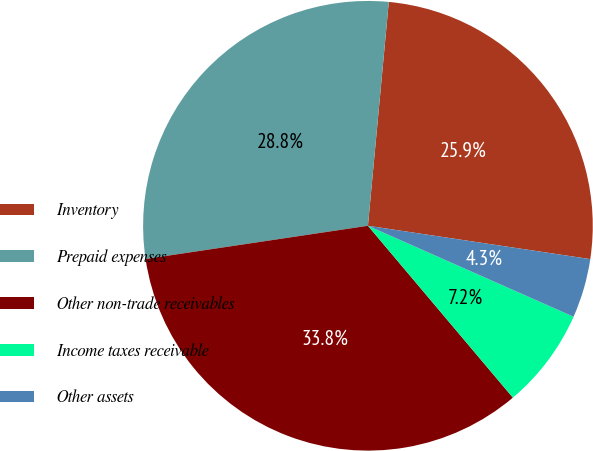Convert chart. <chart><loc_0><loc_0><loc_500><loc_500><pie_chart><fcel>Inventory<fcel>Prepaid expenses<fcel>Other non-trade receivables<fcel>Income taxes receivable<fcel>Other assets<nl><fcel>25.89%<fcel>28.84%<fcel>33.79%<fcel>7.22%<fcel>4.26%<nl></chart> 